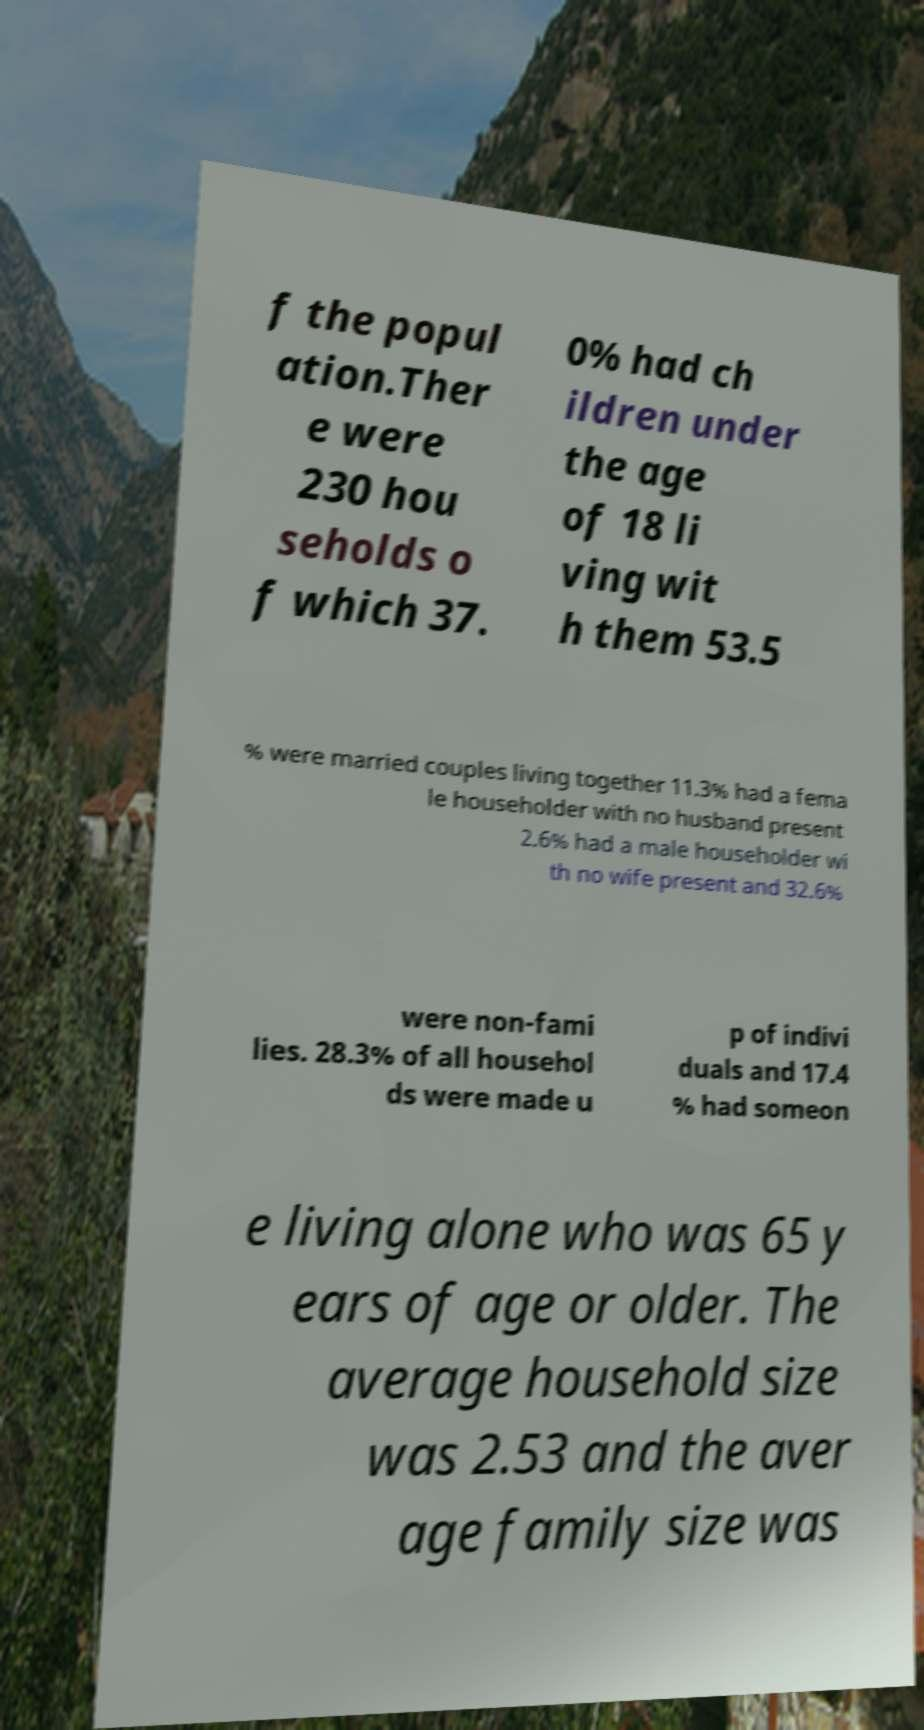There's text embedded in this image that I need extracted. Can you transcribe it verbatim? f the popul ation.Ther e were 230 hou seholds o f which 37. 0% had ch ildren under the age of 18 li ving wit h them 53.5 % were married couples living together 11.3% had a fema le householder with no husband present 2.6% had a male householder wi th no wife present and 32.6% were non-fami lies. 28.3% of all househol ds were made u p of indivi duals and 17.4 % had someon e living alone who was 65 y ears of age or older. The average household size was 2.53 and the aver age family size was 